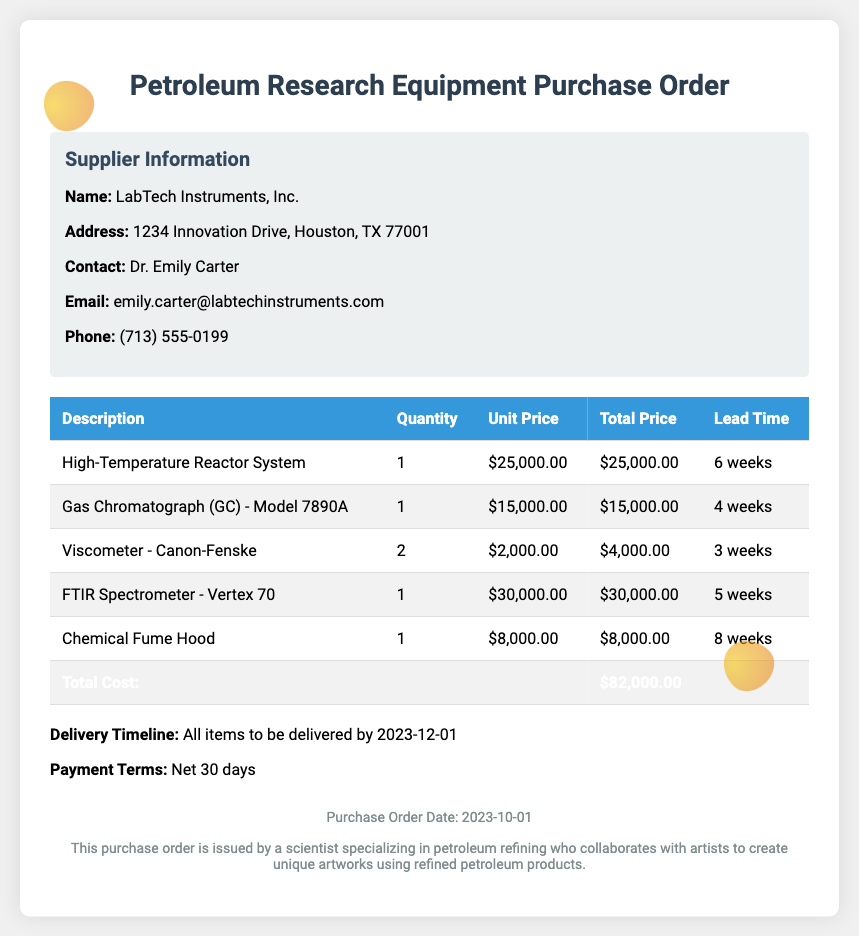What is the total cost of the order? The total cost is calculated by summing the total prices of all items listed in the table, which is $25,000.00 + $15,000.00 + $4,000.00 + $30,000.00 + $8,000.00 = $82,000.00.
Answer: $82,000.00 Who is the contact person for the supplier? The contact person is mentioned under the Supplier Information section of the document.
Answer: Dr. Emily Carter What is the lead time for the Gas Chromatograph? The lead time for each item is listed in the table next to its description.
Answer: 4 weeks When is the delivery timeline for all items? The delivery timeline is explicitly stated in the document to provide clarity on when the items will be received.
Answer: 2023-12-01 What is the payment term for the purchase order? The payment terms section clearly states the conditions for payment related to the order.
Answer: Net 30 days How many Viscometers are ordered? The quantity of each item is specified in the table, particularly for the Viscometer.
Answer: 2 What is the address of the supplier? The address is part of the supplier information provided at the beginning of the document.
Answer: 1234 Innovation Drive, Houston, TX 77001 What date is the purchase order issued? The document includes a specific date indicating when the purchase order was created.
Answer: 2023-10-01 What type of document is this? The title at the top of the document defines its purpose and type.
Answer: Purchase Order 